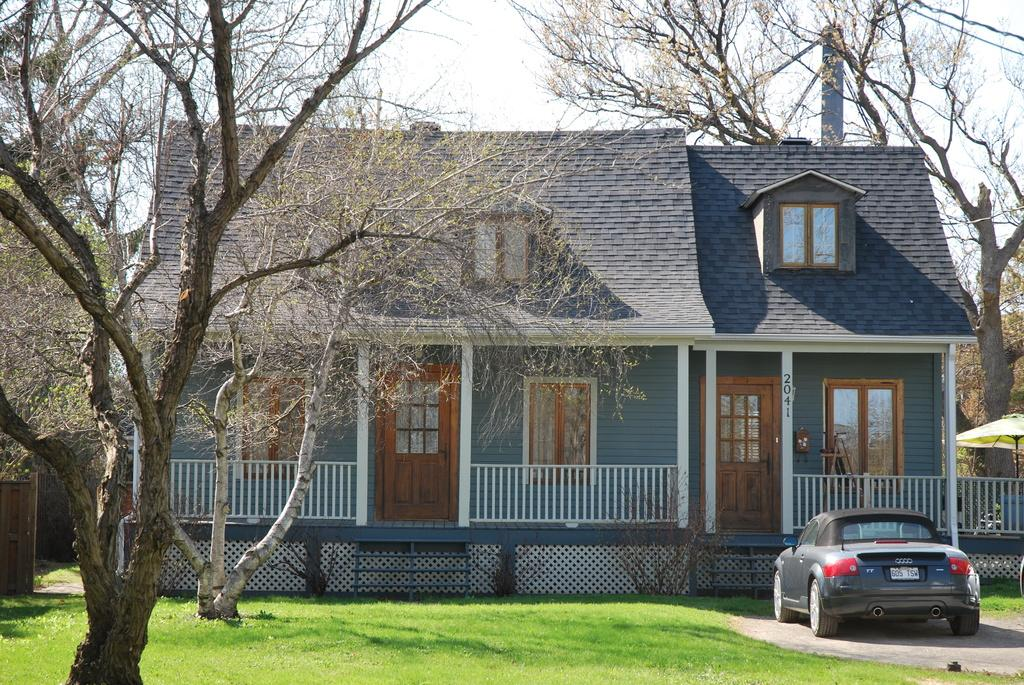What type of structure is present in the image? There is a house in the image. What features can be seen on the house? The house has windows and doors. What type of vegetation is present in the image? There are trees, plants, and grass in the image. What is the purpose of the fence in the image? The fence is likely used to define boundaries or provide privacy. What object is used for protection from the sun in the image? There is an umbrella in the image. What mode of transportation is present in the image? There is a vehicle in the image. What is visible in the background of the image? The sky is visible in the background of the image. Where are the cherries hanging from in the image? There are no cherries present in the image. What type of trousers is the house wearing in the image? The house is not a living being and therefore cannot wear trousers. 